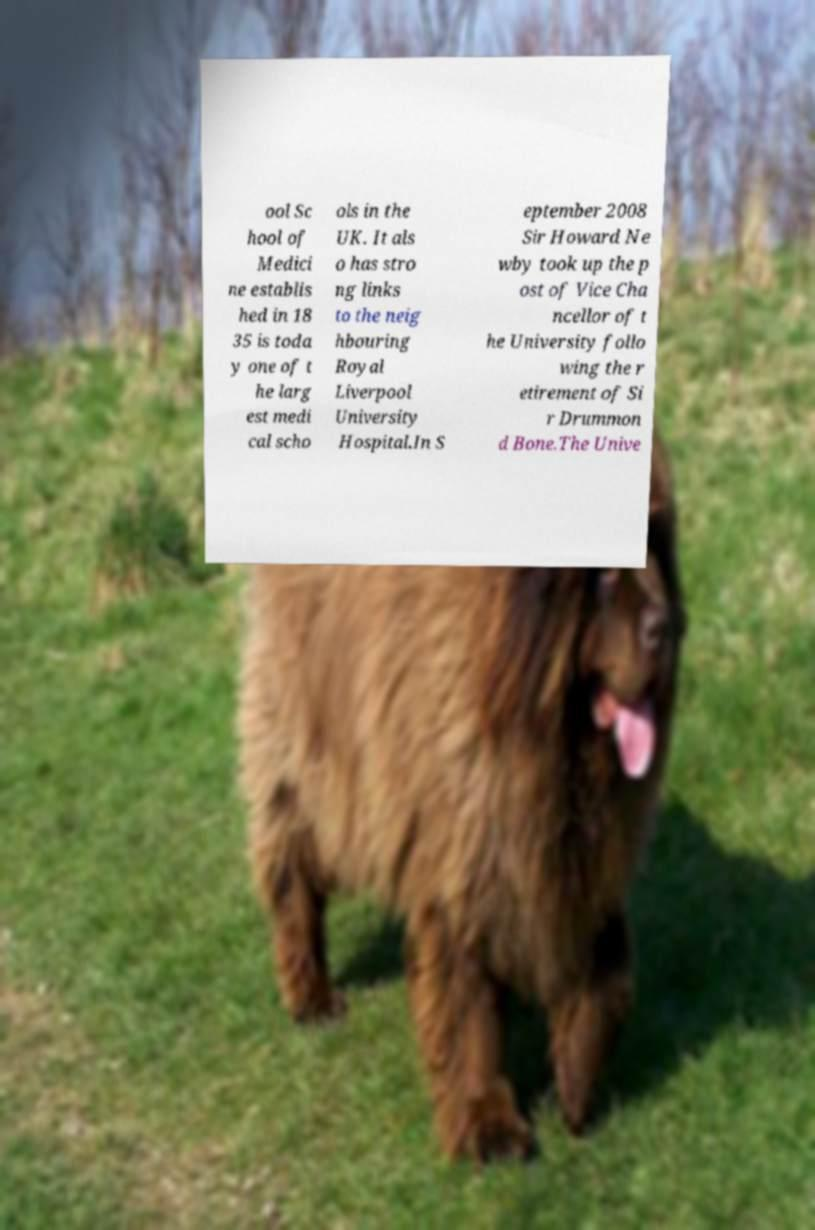Can you accurately transcribe the text from the provided image for me? ool Sc hool of Medici ne establis hed in 18 35 is toda y one of t he larg est medi cal scho ols in the UK. It als o has stro ng links to the neig hbouring Royal Liverpool University Hospital.In S eptember 2008 Sir Howard Ne wby took up the p ost of Vice Cha ncellor of t he University follo wing the r etirement of Si r Drummon d Bone.The Unive 